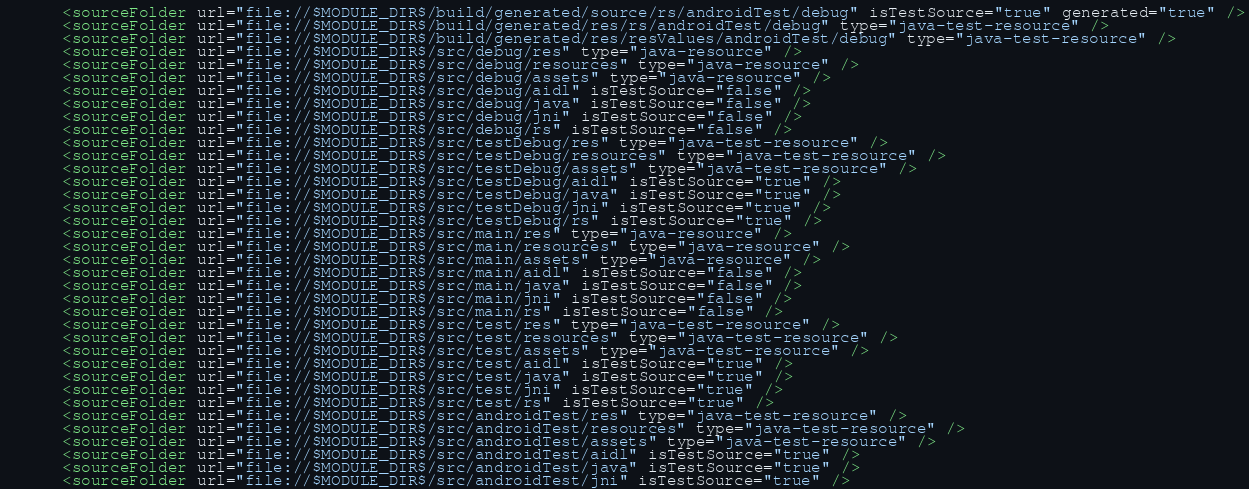Convert code to text. <code><loc_0><loc_0><loc_500><loc_500><_XML_>      <sourceFolder url="file://$MODULE_DIR$/build/generated/source/rs/androidTest/debug" isTestSource="true" generated="true" />
      <sourceFolder url="file://$MODULE_DIR$/build/generated/res/rs/androidTest/debug" type="java-test-resource" />
      <sourceFolder url="file://$MODULE_DIR$/build/generated/res/resValues/androidTest/debug" type="java-test-resource" />
      <sourceFolder url="file://$MODULE_DIR$/src/debug/res" type="java-resource" />
      <sourceFolder url="file://$MODULE_DIR$/src/debug/resources" type="java-resource" />
      <sourceFolder url="file://$MODULE_DIR$/src/debug/assets" type="java-resource" />
      <sourceFolder url="file://$MODULE_DIR$/src/debug/aidl" isTestSource="false" />
      <sourceFolder url="file://$MODULE_DIR$/src/debug/java" isTestSource="false" />
      <sourceFolder url="file://$MODULE_DIR$/src/debug/jni" isTestSource="false" />
      <sourceFolder url="file://$MODULE_DIR$/src/debug/rs" isTestSource="false" />
      <sourceFolder url="file://$MODULE_DIR$/src/testDebug/res" type="java-test-resource" />
      <sourceFolder url="file://$MODULE_DIR$/src/testDebug/resources" type="java-test-resource" />
      <sourceFolder url="file://$MODULE_DIR$/src/testDebug/assets" type="java-test-resource" />
      <sourceFolder url="file://$MODULE_DIR$/src/testDebug/aidl" isTestSource="true" />
      <sourceFolder url="file://$MODULE_DIR$/src/testDebug/java" isTestSource="true" />
      <sourceFolder url="file://$MODULE_DIR$/src/testDebug/jni" isTestSource="true" />
      <sourceFolder url="file://$MODULE_DIR$/src/testDebug/rs" isTestSource="true" />
      <sourceFolder url="file://$MODULE_DIR$/src/main/res" type="java-resource" />
      <sourceFolder url="file://$MODULE_DIR$/src/main/resources" type="java-resource" />
      <sourceFolder url="file://$MODULE_DIR$/src/main/assets" type="java-resource" />
      <sourceFolder url="file://$MODULE_DIR$/src/main/aidl" isTestSource="false" />
      <sourceFolder url="file://$MODULE_DIR$/src/main/java" isTestSource="false" />
      <sourceFolder url="file://$MODULE_DIR$/src/main/jni" isTestSource="false" />
      <sourceFolder url="file://$MODULE_DIR$/src/main/rs" isTestSource="false" />
      <sourceFolder url="file://$MODULE_DIR$/src/test/res" type="java-test-resource" />
      <sourceFolder url="file://$MODULE_DIR$/src/test/resources" type="java-test-resource" />
      <sourceFolder url="file://$MODULE_DIR$/src/test/assets" type="java-test-resource" />
      <sourceFolder url="file://$MODULE_DIR$/src/test/aidl" isTestSource="true" />
      <sourceFolder url="file://$MODULE_DIR$/src/test/java" isTestSource="true" />
      <sourceFolder url="file://$MODULE_DIR$/src/test/jni" isTestSource="true" />
      <sourceFolder url="file://$MODULE_DIR$/src/test/rs" isTestSource="true" />
      <sourceFolder url="file://$MODULE_DIR$/src/androidTest/res" type="java-test-resource" />
      <sourceFolder url="file://$MODULE_DIR$/src/androidTest/resources" type="java-test-resource" />
      <sourceFolder url="file://$MODULE_DIR$/src/androidTest/assets" type="java-test-resource" />
      <sourceFolder url="file://$MODULE_DIR$/src/androidTest/aidl" isTestSource="true" />
      <sourceFolder url="file://$MODULE_DIR$/src/androidTest/java" isTestSource="true" />
      <sourceFolder url="file://$MODULE_DIR$/src/androidTest/jni" isTestSource="true" /></code> 